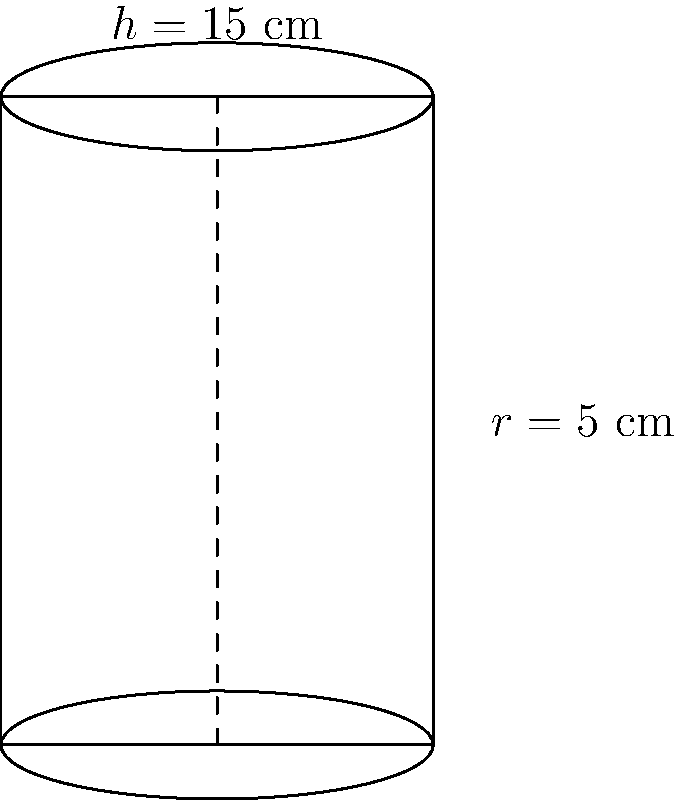As the PTA leader organizing a school fundraiser, you've decided to use cylindrical jars for donations. The jar has a radius of 5 cm and a height of 15 cm. Calculate the volume of the donation jar to determine its capacity. Round your answer to the nearest whole number. To calculate the volume of a cylindrical jar, we'll use the formula for the volume of a cylinder:

$$V = \pi r^2 h$$

Where:
$V$ = volume
$r$ = radius
$h$ = height

Given:
$r = 5$ cm
$h = 15$ cm

Let's solve step-by-step:

1) Substitute the values into the formula:
   $$V = \pi (5\text{ cm})^2 (15\text{ cm})$$

2) Calculate $r^2$:
   $$V = \pi (25\text{ cm}^2) (15\text{ cm})$$

3) Multiply the values inside the parentheses:
   $$V = \pi (375\text{ cm}^3)$$

4) Multiply by $\pi$ (use 3.14159 for $\pi$):
   $$V = 1,177.59625\text{ cm}^3$$

5) Round to the nearest whole number:
   $$V \approx 1,178\text{ cm}^3$$

Therefore, the volume of the donation jar is approximately 1,178 cubic centimeters.
Answer: 1,178 cm³ 